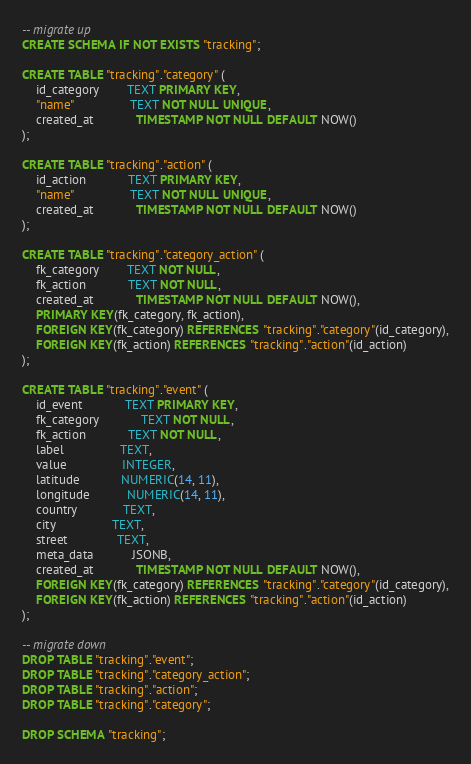Convert code to text. <code><loc_0><loc_0><loc_500><loc_500><_SQL_>
-- migrate up
CREATE SCHEMA IF NOT EXISTS "tracking";

CREATE TABLE "tracking"."category" (
	id_category 		TEXT PRIMARY KEY,
	"name"		        TEXT NOT NULL UNIQUE,
	created_at			TIMESTAMP NOT NULL DEFAULT NOW()
);

CREATE TABLE "tracking"."action" (
	id_action 		    TEXT PRIMARY KEY,
	"name"		        TEXT NOT NULL UNIQUE,
	created_at			TIMESTAMP NOT NULL DEFAULT NOW()
);

CREATE TABLE "tracking"."category_action" (
	fk_category 	    TEXT NOT NULL,
	fk_action	        TEXT NOT NULL,
	created_at			TIMESTAMP NOT NULL DEFAULT NOW(),
	PRIMARY KEY(fk_category, fk_action),
	FOREIGN KEY(fk_category) REFERENCES "tracking"."category"(id_category),
	FOREIGN KEY(fk_action) REFERENCES "tracking"."action"(id_action)
);

CREATE TABLE "tracking"."event" (
	id_event 		    TEXT PRIMARY KEY,
	fk_category		    TEXT NOT NULL,
	fk_action  			TEXT NOT NULL,
	label 				TEXT,
	value              	INTEGER,
	latitude            NUMERIC(14, 11),
	longitude           NUMERIC(14, 11),
	country             TEXT,
	city                TEXT,
	street              TEXT,
	meta_data           JSONB,
	created_at			TIMESTAMP NOT NULL DEFAULT NOW(),
	FOREIGN KEY(fk_category) REFERENCES "tracking"."category"(id_category),
	FOREIGN KEY(fk_action) REFERENCES "tracking"."action"(id_action)
);

-- migrate down
DROP TABLE "tracking"."event";
DROP TABLE "tracking"."category_action";
DROP TABLE "tracking"."action";
DROP TABLE "tracking"."category";

DROP SCHEMA "tracking";
</code> 